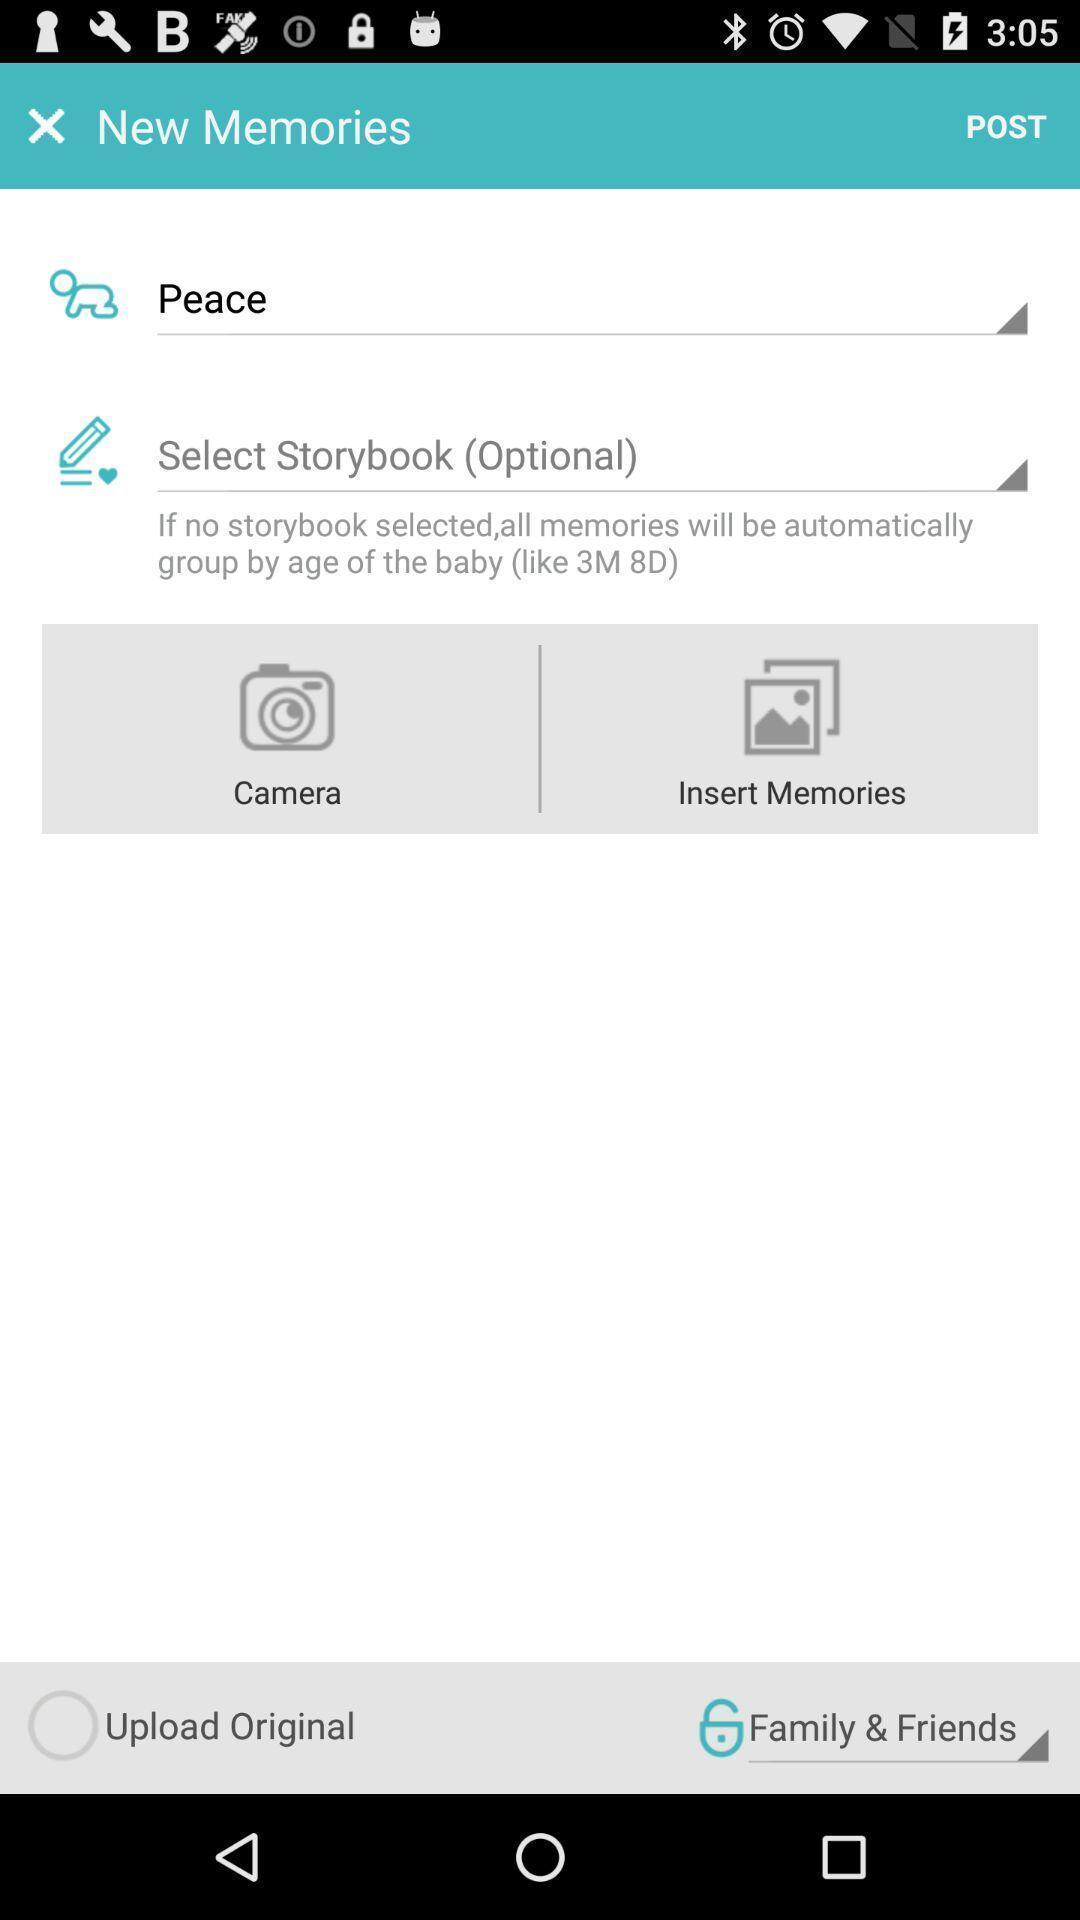Explain what's happening in this screen capture. Screen displaying multiple post options in memories page. 